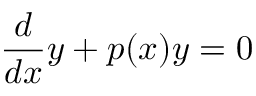Convert formula to latex. <formula><loc_0><loc_0><loc_500><loc_500>{ \frac { d } { d x } } y + p ( x ) y = 0</formula> 